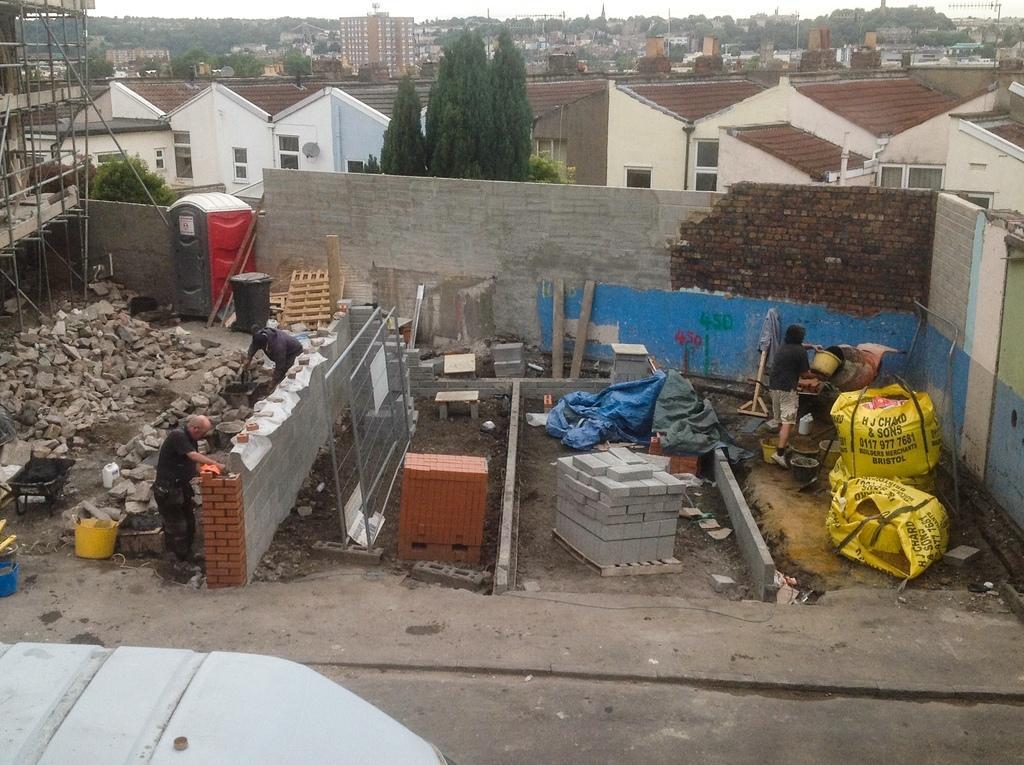How would you summarize this image in a sentence or two? In this image we can see some persons who are constructing house and in the background of the image there are some houses, trees and clear sky. 